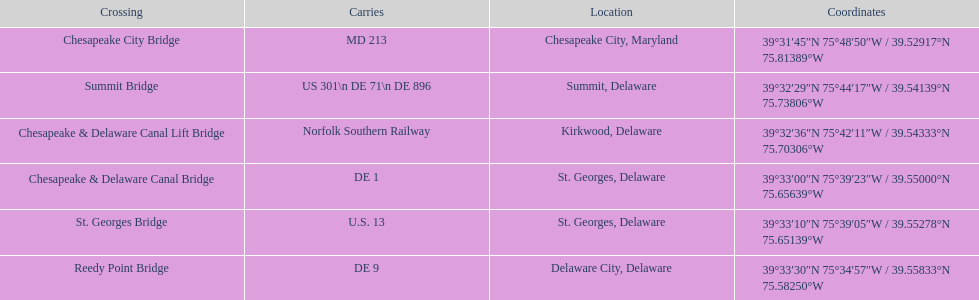At which junction are the most routes found (e.g., de 1)? Summit Bridge. 